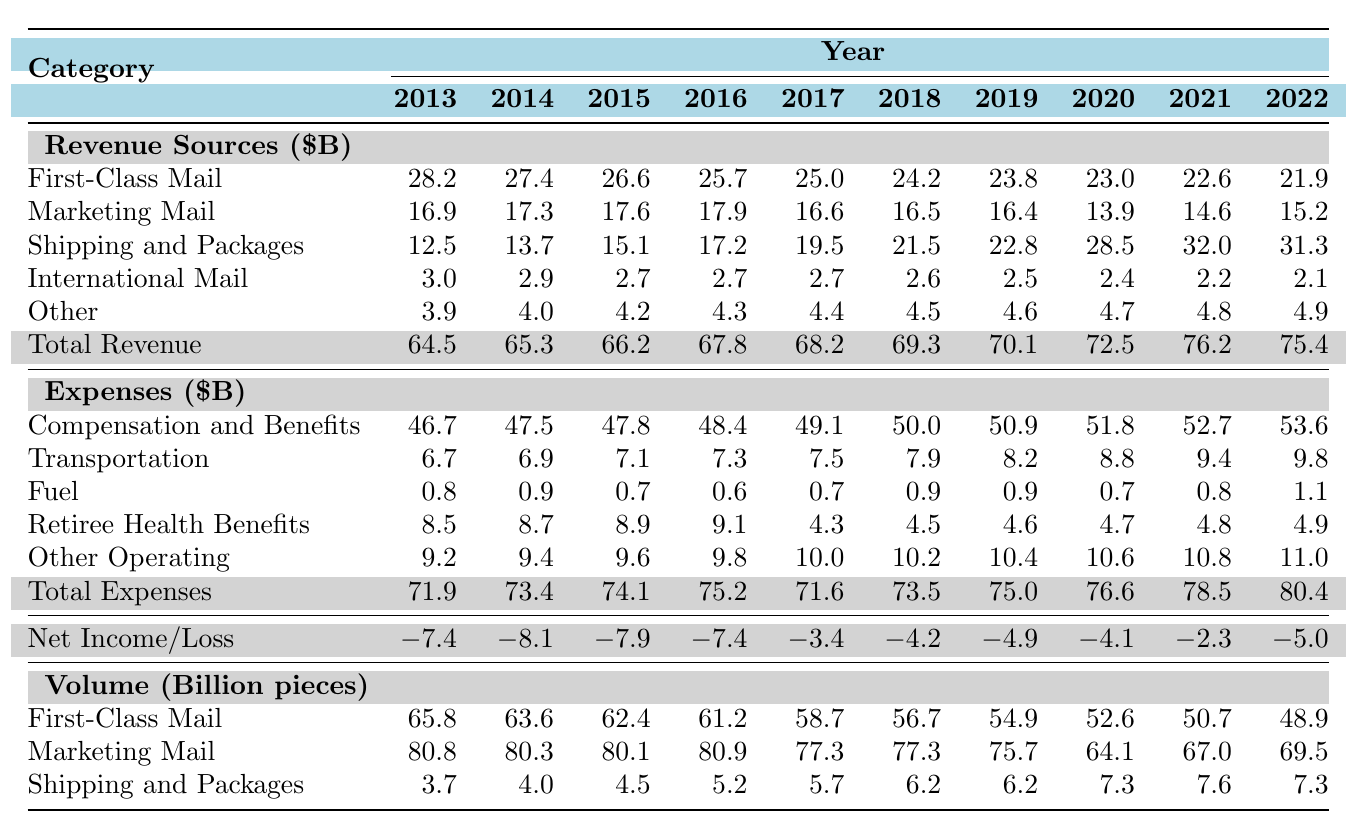What was the total revenue for USPS in 2022? Looking at the row labeled "Total Revenue," the value in the column for 2022 is 75.4 billion dollars.
Answer: 75.4 billion dollars Which revenue source experienced the largest increase in revenue from 2013 to 2021? To determine the largest increase, we compare the revenue for each source in 2013 and 2021. The revenue for Shipping and Packages increased from 12.5 billion to 32.0 billion. Other sources either decreased or did not match this increase.
Answer: Shipping and Packages What was the net income or loss for USPS in 2018? From the row labeled "Net Income/Loss," the figure for 2018 is -4.2 billion dollars, indicating a loss.
Answer: -4.2 billion dollars Did the Compensation and Benefits Expenses in 2021 exceed the Total Revenue for that year? The Total Revenue in 2021 was 76.2 billion dollars, and Compensation and Benefits Expenses were 52.7 billion dollars. Since 52.7 is less than 76.2, the statement is true.
Answer: No What was the total volume of Marketing Mail pieces sent in 2019? The specific value for Marketing Mail Volume in 2019 is found in that row's corresponding column, which shows 75.7 billion pieces.
Answer: 75.7 billion pieces What is the percentage decrease in First-Class Mail revenue from 2013 to 2022? First-Class Mail revenue in 2013 was 28.2 billion and in 2022 was 21.9 billion. The decrease is 28.2 - 21.9 = 6.3 billion. To find the percentage decrease: (6.3 / 28.2) x 100 = 22.34%.
Answer: 22.34% Which category had the lowest revenue in 2016? By examining the revenue sources for 2016, the category with the lowest revenue that year was International Mail at 2.7 billion dollars.
Answer: International Mail What is the trend in total expenses from 2013 to 2022? The Total Expenses increased from 71.9 billion in 2013 to 80.4 billion in 2022. Observing this, it is clear there is a rising trend over the years.
Answer: Rising trend In what year did USPS report its highest revenue? Observing the Total Revenue row, the highest value was in 2021 at 76.2 billion dollars.
Answer: 2021 Calculate the average Shipping and Packages revenue from 2013 to 2022. Adding up the revenues from each year: (12.5 + 13.7 + 15.1 + 17.2 + 19.5 + 21.5 + 22.8 + 28.5 + 32.0 + 31.3) gives a total of  221.1 billion. Dividing by 10, the average is 22.11 billion dollars.
Answer: 22.11 billion dollars 